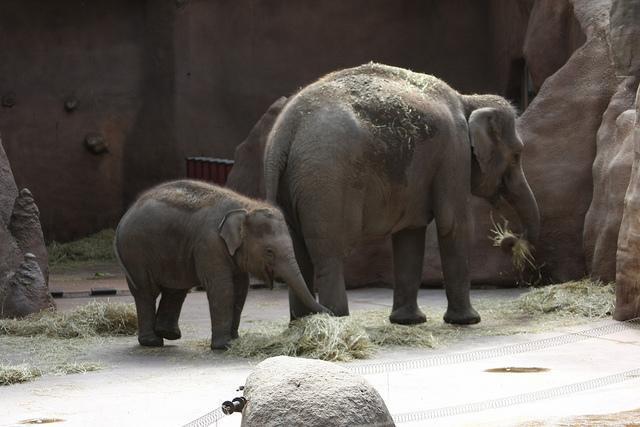How many elephants are there?
Give a very brief answer. 2. 